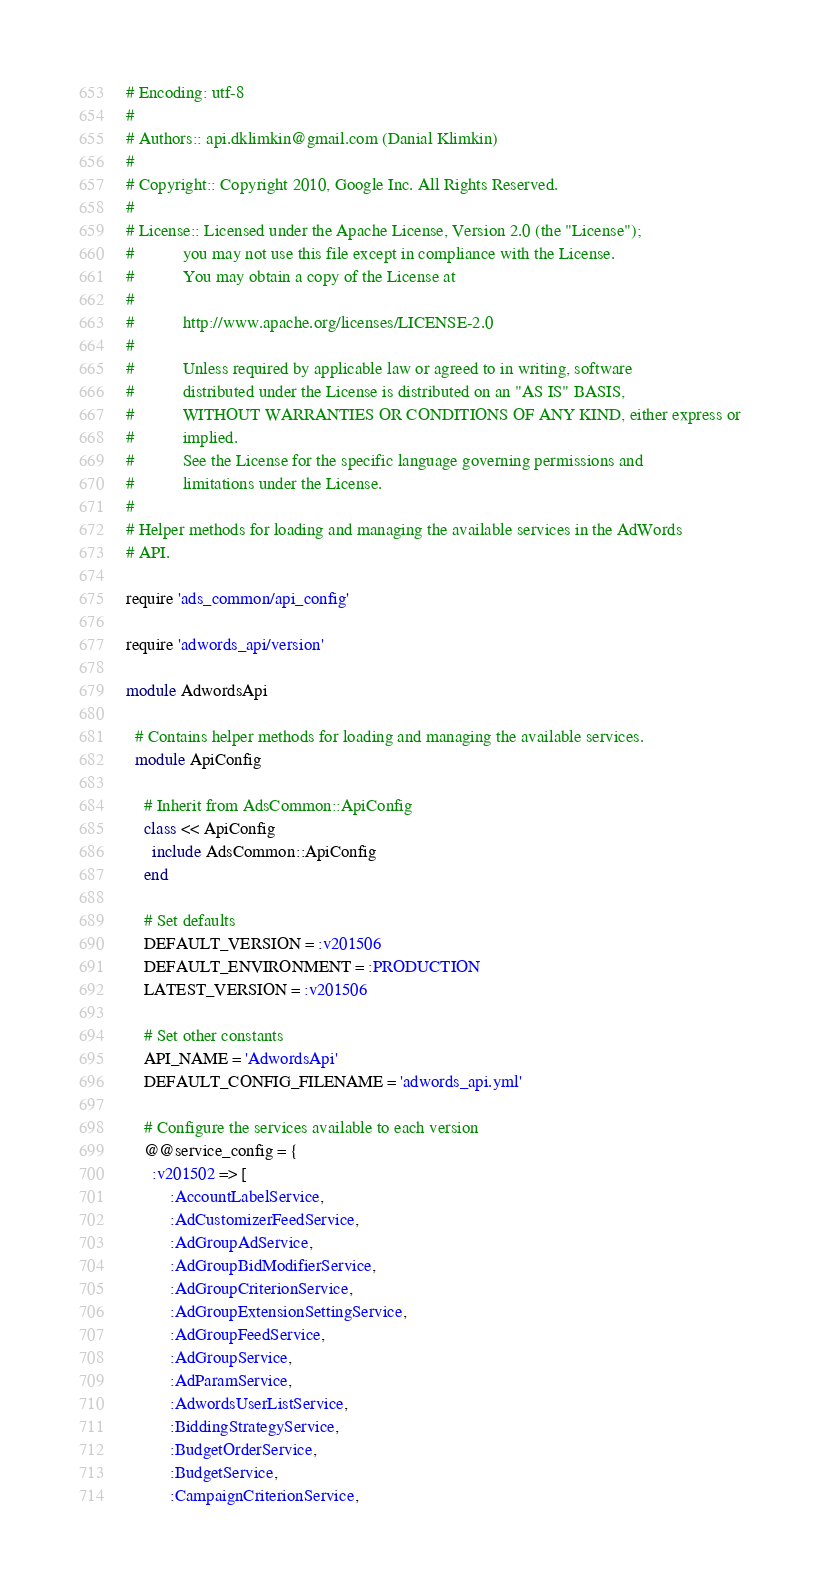Convert code to text. <code><loc_0><loc_0><loc_500><loc_500><_Ruby_># Encoding: utf-8
#
# Authors:: api.dklimkin@gmail.com (Danial Klimkin)
#
# Copyright:: Copyright 2010, Google Inc. All Rights Reserved.
#
# License:: Licensed under the Apache License, Version 2.0 (the "License");
#           you may not use this file except in compliance with the License.
#           You may obtain a copy of the License at
#
#           http://www.apache.org/licenses/LICENSE-2.0
#
#           Unless required by applicable law or agreed to in writing, software
#           distributed under the License is distributed on an "AS IS" BASIS,
#           WITHOUT WARRANTIES OR CONDITIONS OF ANY KIND, either express or
#           implied.
#           See the License for the specific language governing permissions and
#           limitations under the License.
#
# Helper methods for loading and managing the available services in the AdWords
# API.

require 'ads_common/api_config'

require 'adwords_api/version'

module AdwordsApi

  # Contains helper methods for loading and managing the available services.
  module ApiConfig

    # Inherit from AdsCommon::ApiConfig
    class << ApiConfig
      include AdsCommon::ApiConfig
    end

    # Set defaults
    DEFAULT_VERSION = :v201506
    DEFAULT_ENVIRONMENT = :PRODUCTION
    LATEST_VERSION = :v201506

    # Set other constants
    API_NAME = 'AdwordsApi'
    DEFAULT_CONFIG_FILENAME = 'adwords_api.yml'

    # Configure the services available to each version
    @@service_config = {
      :v201502 => [
          :AccountLabelService,
          :AdCustomizerFeedService,
          :AdGroupAdService,
          :AdGroupBidModifierService,
          :AdGroupCriterionService,
          :AdGroupExtensionSettingService,
          :AdGroupFeedService,
          :AdGroupService,
          :AdParamService,
          :AdwordsUserListService,
          :BiddingStrategyService,
          :BudgetOrderService,
          :BudgetService,
          :CampaignCriterionService,</code> 